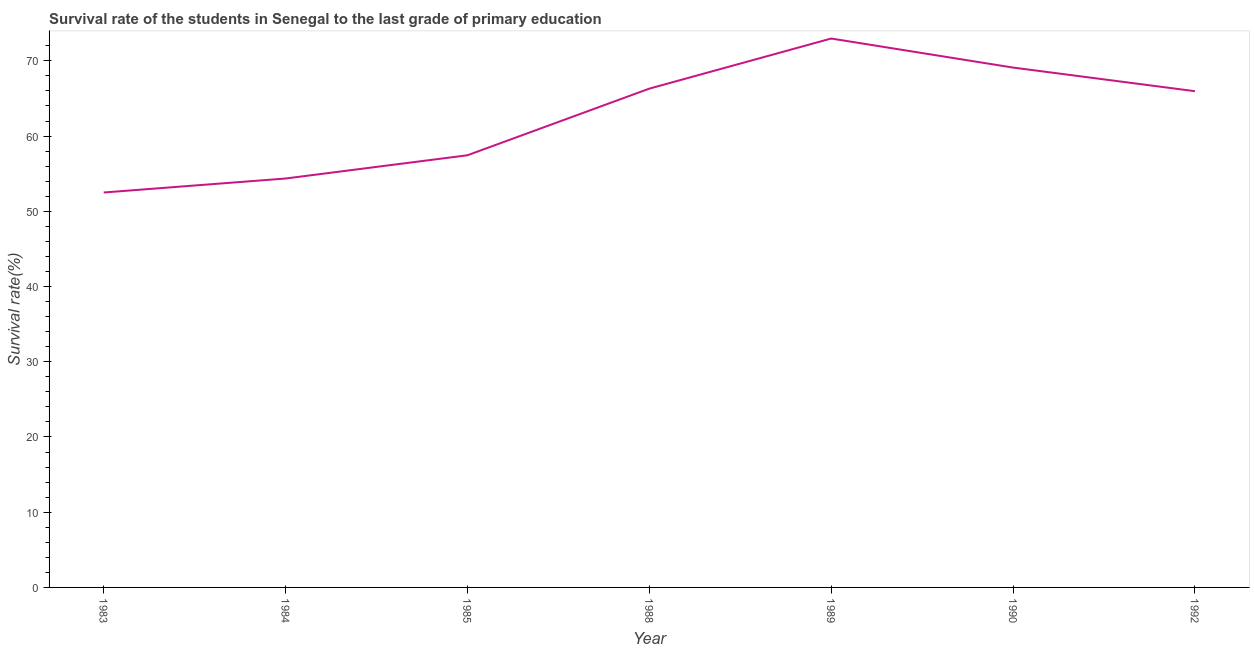What is the survival rate in primary education in 1990?
Ensure brevity in your answer.  69.1. Across all years, what is the maximum survival rate in primary education?
Make the answer very short. 72.97. Across all years, what is the minimum survival rate in primary education?
Give a very brief answer. 52.5. In which year was the survival rate in primary education maximum?
Provide a short and direct response. 1989. What is the sum of the survival rate in primary education?
Give a very brief answer. 438.64. What is the difference between the survival rate in primary education in 1985 and 1992?
Your answer should be very brief. -8.52. What is the average survival rate in primary education per year?
Ensure brevity in your answer.  62.66. What is the median survival rate in primary education?
Your answer should be very brief. 65.96. What is the ratio of the survival rate in primary education in 1985 to that in 1989?
Provide a short and direct response. 0.79. Is the difference between the survival rate in primary education in 1990 and 1992 greater than the difference between any two years?
Offer a terse response. No. What is the difference between the highest and the second highest survival rate in primary education?
Your answer should be compact. 3.86. Is the sum of the survival rate in primary education in 1983 and 1992 greater than the maximum survival rate in primary education across all years?
Keep it short and to the point. Yes. What is the difference between the highest and the lowest survival rate in primary education?
Keep it short and to the point. 20.47. In how many years, is the survival rate in primary education greater than the average survival rate in primary education taken over all years?
Ensure brevity in your answer.  4. Does the survival rate in primary education monotonically increase over the years?
Keep it short and to the point. No. How many years are there in the graph?
Ensure brevity in your answer.  7. What is the difference between two consecutive major ticks on the Y-axis?
Offer a very short reply. 10. Does the graph contain any zero values?
Offer a terse response. No. What is the title of the graph?
Offer a terse response. Survival rate of the students in Senegal to the last grade of primary education. What is the label or title of the X-axis?
Your answer should be compact. Year. What is the label or title of the Y-axis?
Your response must be concise. Survival rate(%). What is the Survival rate(%) in 1983?
Your answer should be compact. 52.5. What is the Survival rate(%) in 1984?
Give a very brief answer. 54.36. What is the Survival rate(%) in 1985?
Give a very brief answer. 57.45. What is the Survival rate(%) in 1988?
Provide a succinct answer. 66.3. What is the Survival rate(%) in 1989?
Provide a short and direct response. 72.97. What is the Survival rate(%) of 1990?
Your answer should be compact. 69.1. What is the Survival rate(%) of 1992?
Your answer should be compact. 65.96. What is the difference between the Survival rate(%) in 1983 and 1984?
Your answer should be compact. -1.86. What is the difference between the Survival rate(%) in 1983 and 1985?
Ensure brevity in your answer.  -4.95. What is the difference between the Survival rate(%) in 1983 and 1988?
Offer a terse response. -13.81. What is the difference between the Survival rate(%) in 1983 and 1989?
Your answer should be compact. -20.47. What is the difference between the Survival rate(%) in 1983 and 1990?
Keep it short and to the point. -16.61. What is the difference between the Survival rate(%) in 1983 and 1992?
Your response must be concise. -13.47. What is the difference between the Survival rate(%) in 1984 and 1985?
Your answer should be very brief. -3.09. What is the difference between the Survival rate(%) in 1984 and 1988?
Your response must be concise. -11.95. What is the difference between the Survival rate(%) in 1984 and 1989?
Offer a terse response. -18.61. What is the difference between the Survival rate(%) in 1984 and 1990?
Your answer should be compact. -14.75. What is the difference between the Survival rate(%) in 1984 and 1992?
Your response must be concise. -11.61. What is the difference between the Survival rate(%) in 1985 and 1988?
Keep it short and to the point. -8.86. What is the difference between the Survival rate(%) in 1985 and 1989?
Give a very brief answer. -15.52. What is the difference between the Survival rate(%) in 1985 and 1990?
Give a very brief answer. -11.66. What is the difference between the Survival rate(%) in 1985 and 1992?
Keep it short and to the point. -8.52. What is the difference between the Survival rate(%) in 1988 and 1989?
Your answer should be compact. -6.66. What is the difference between the Survival rate(%) in 1988 and 1990?
Give a very brief answer. -2.8. What is the difference between the Survival rate(%) in 1988 and 1992?
Give a very brief answer. 0.34. What is the difference between the Survival rate(%) in 1989 and 1990?
Your response must be concise. 3.86. What is the difference between the Survival rate(%) in 1989 and 1992?
Keep it short and to the point. 7. What is the difference between the Survival rate(%) in 1990 and 1992?
Give a very brief answer. 3.14. What is the ratio of the Survival rate(%) in 1983 to that in 1984?
Your response must be concise. 0.97. What is the ratio of the Survival rate(%) in 1983 to that in 1985?
Your response must be concise. 0.91. What is the ratio of the Survival rate(%) in 1983 to that in 1988?
Your answer should be compact. 0.79. What is the ratio of the Survival rate(%) in 1983 to that in 1989?
Provide a succinct answer. 0.72. What is the ratio of the Survival rate(%) in 1983 to that in 1990?
Provide a succinct answer. 0.76. What is the ratio of the Survival rate(%) in 1983 to that in 1992?
Ensure brevity in your answer.  0.8. What is the ratio of the Survival rate(%) in 1984 to that in 1985?
Offer a terse response. 0.95. What is the ratio of the Survival rate(%) in 1984 to that in 1988?
Provide a short and direct response. 0.82. What is the ratio of the Survival rate(%) in 1984 to that in 1989?
Make the answer very short. 0.74. What is the ratio of the Survival rate(%) in 1984 to that in 1990?
Provide a succinct answer. 0.79. What is the ratio of the Survival rate(%) in 1984 to that in 1992?
Offer a terse response. 0.82. What is the ratio of the Survival rate(%) in 1985 to that in 1988?
Provide a short and direct response. 0.87. What is the ratio of the Survival rate(%) in 1985 to that in 1989?
Ensure brevity in your answer.  0.79. What is the ratio of the Survival rate(%) in 1985 to that in 1990?
Keep it short and to the point. 0.83. What is the ratio of the Survival rate(%) in 1985 to that in 1992?
Your response must be concise. 0.87. What is the ratio of the Survival rate(%) in 1988 to that in 1989?
Provide a succinct answer. 0.91. What is the ratio of the Survival rate(%) in 1989 to that in 1990?
Ensure brevity in your answer.  1.06. What is the ratio of the Survival rate(%) in 1989 to that in 1992?
Keep it short and to the point. 1.11. What is the ratio of the Survival rate(%) in 1990 to that in 1992?
Ensure brevity in your answer.  1.05. 